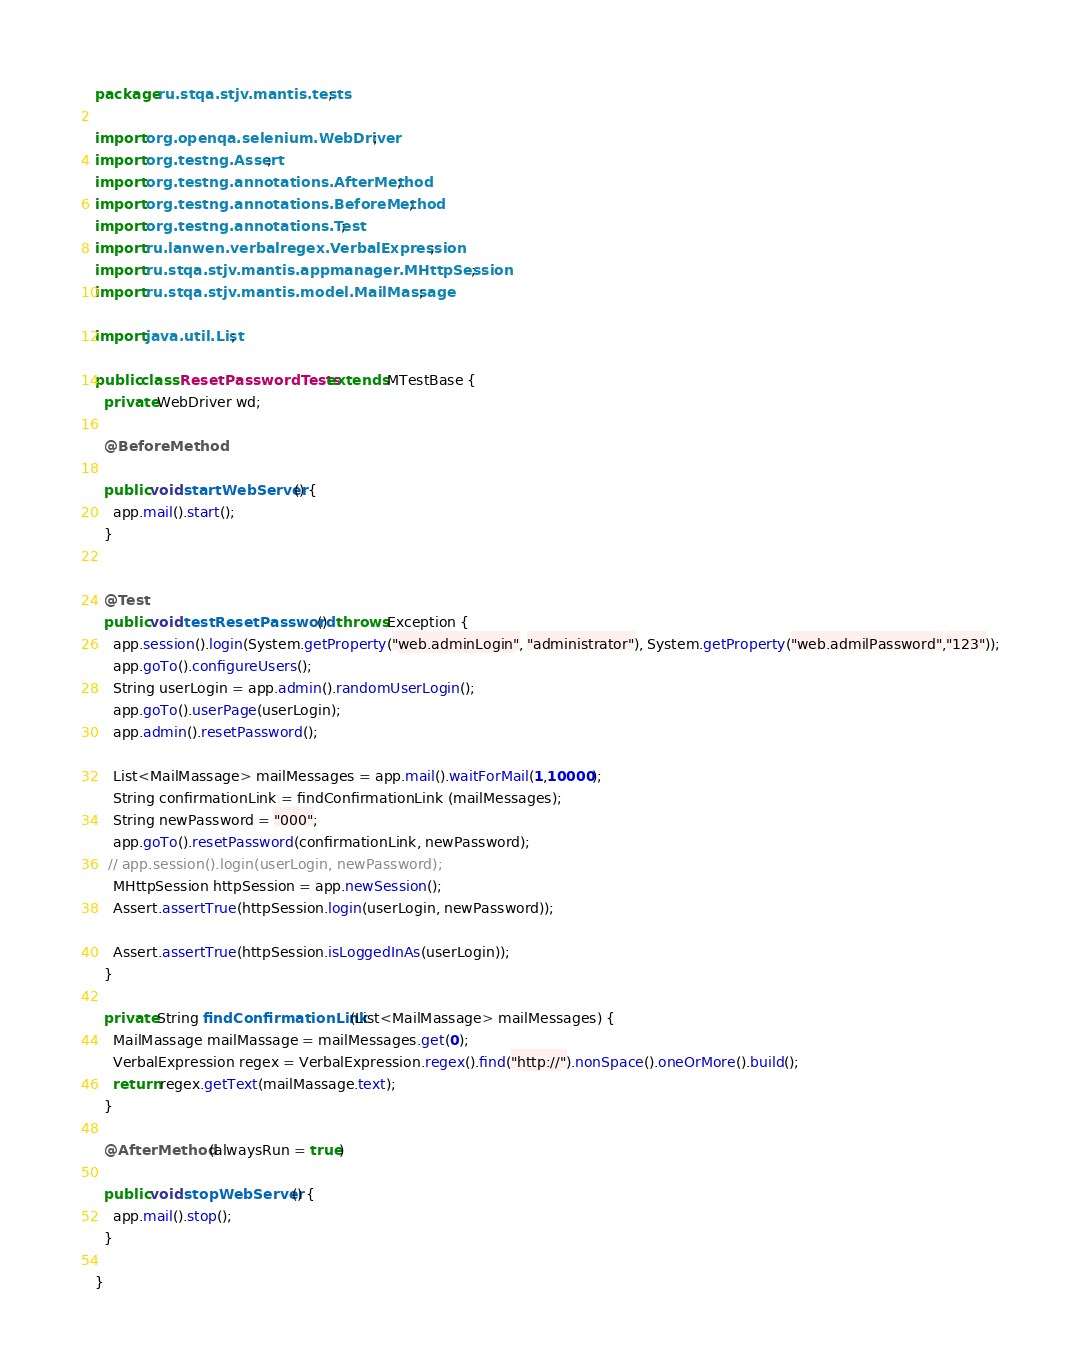<code> <loc_0><loc_0><loc_500><loc_500><_Java_>package ru.stqa.stjv.mantis.tests;

import org.openqa.selenium.WebDriver;
import org.testng.Assert;
import org.testng.annotations.AfterMethod;
import org.testng.annotations.BeforeMethod;
import org.testng.annotations.Test;
import ru.lanwen.verbalregex.VerbalExpression;
import ru.stqa.stjv.mantis.appmanager.MHttpSession;
import ru.stqa.stjv.mantis.model.MailMassage;

import java.util.List;

public class ResetPasswordTests extends MTestBase {
  private WebDriver wd;

  @BeforeMethod

  public void startWebServer() {
    app.mail().start();
  }


  @Test
  public void testResetPassword()  throws Exception {
    app.session().login(System.getProperty("web.adminLogin", "administrator"), System.getProperty("web.admilPassword","123"));
    app.goTo().configureUsers();
    String userLogin = app.admin().randomUserLogin();
    app.goTo().userPage(userLogin);
    app.admin().resetPassword();

    List<MailMassage> mailMessages = app.mail().waitForMail(1,10000);
    String confirmationLink = findConfirmationLink (mailMessages);
    String newPassword = "000";
    app.goTo().resetPassword(confirmationLink, newPassword);
   // app.session().login(userLogin, newPassword);
    MHttpSession httpSession = app.newSession();
    Assert.assertTrue(httpSession.login(userLogin, newPassword));

    Assert.assertTrue(httpSession.isLoggedInAs(userLogin));
  }

  private String findConfirmationLink(List<MailMassage> mailMessages) {
    MailMassage mailMassage = mailMessages.get(0);
    VerbalExpression regex = VerbalExpression.regex().find("http://").nonSpace().oneOrMore().build();
    return regex.getText(mailMassage.text);
  }

  @AfterMethod (alwaysRun = true)

  public void stopWebServer() {
    app.mail().stop();
  }

}
</code> 